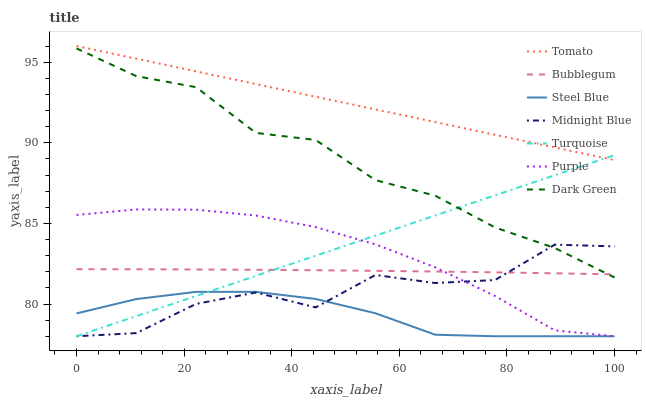Does Steel Blue have the minimum area under the curve?
Answer yes or no. Yes. Does Tomato have the maximum area under the curve?
Answer yes or no. Yes. Does Turquoise have the minimum area under the curve?
Answer yes or no. No. Does Turquoise have the maximum area under the curve?
Answer yes or no. No. Is Tomato the smoothest?
Answer yes or no. Yes. Is Midnight Blue the roughest?
Answer yes or no. Yes. Is Turquoise the smoothest?
Answer yes or no. No. Is Turquoise the roughest?
Answer yes or no. No. Does Turquoise have the lowest value?
Answer yes or no. Yes. Does Bubblegum have the lowest value?
Answer yes or no. No. Does Tomato have the highest value?
Answer yes or no. Yes. Does Turquoise have the highest value?
Answer yes or no. No. Is Steel Blue less than Tomato?
Answer yes or no. Yes. Is Bubblegum greater than Steel Blue?
Answer yes or no. Yes. Does Bubblegum intersect Turquoise?
Answer yes or no. Yes. Is Bubblegum less than Turquoise?
Answer yes or no. No. Is Bubblegum greater than Turquoise?
Answer yes or no. No. Does Steel Blue intersect Tomato?
Answer yes or no. No. 